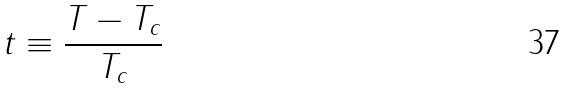Convert formula to latex. <formula><loc_0><loc_0><loc_500><loc_500>t \equiv \frac { T - T _ { c } } { T _ { c } }</formula> 